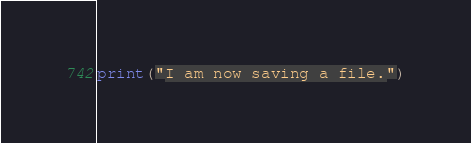<code> <loc_0><loc_0><loc_500><loc_500><_Python_>print("I am now saving a file.")</code> 